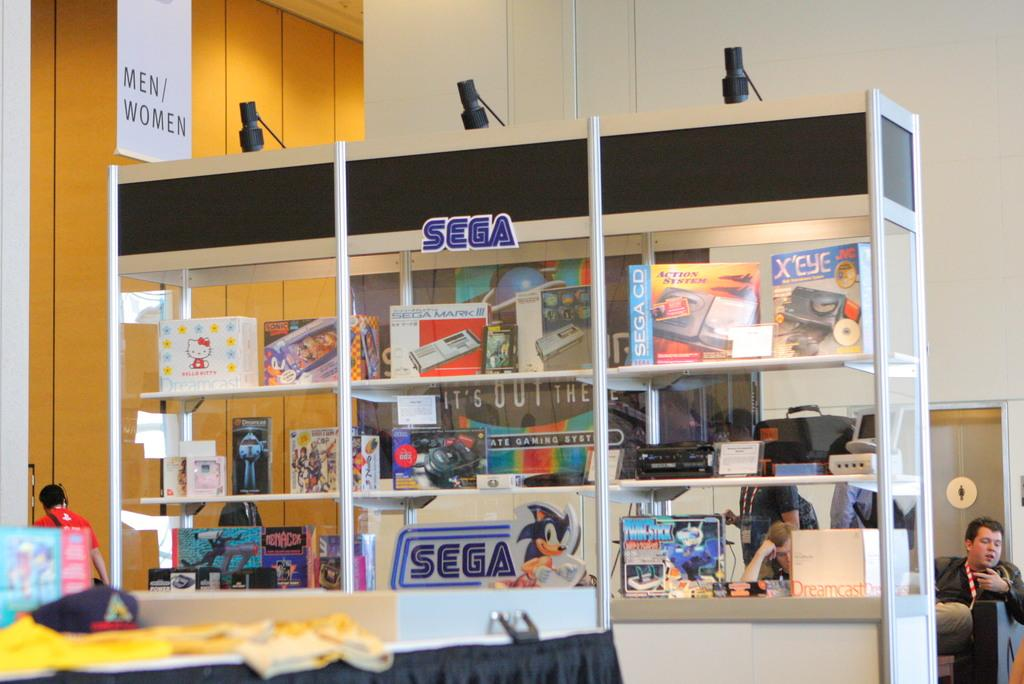<image>
Offer a succinct explanation of the picture presented. A glass display box proudnly displays many Sega items 